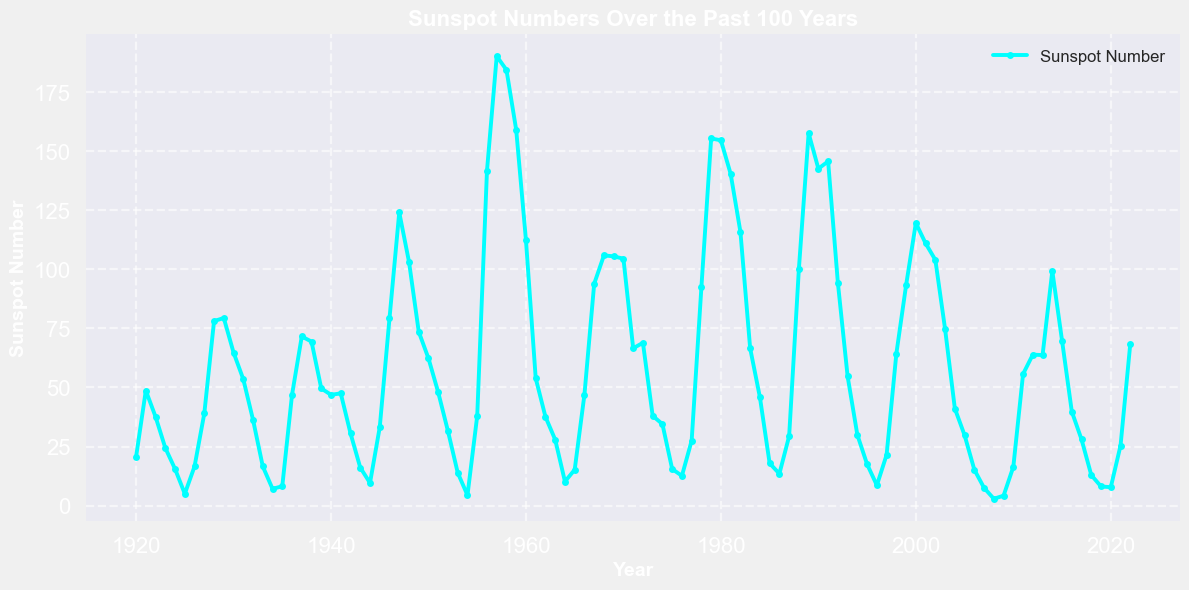What year had the highest sunspot number? To find the highest sunspot number, look for the peak value in the chart. The highest value corresponds to the year 1957 with a sunspot number of 190.2.
Answer: 1957 Which decade experienced the lowest sunspot numbers overall? Sum the sunspot numbers for each decade and compare the totals. The 1920s had a cumulative sunspot number of (20.6 + 48.7 + 37.6 + 24.4 + 15.5 + 5.0 + 16.6 + 39.0 + 78.1 + 79.4) = 365.9, which is the lowest of any decade.
Answer: 1920s What are the two closest consecutive years with a large difference in sunspot numbers? To determine the closest consecutive years with the largest difference, look for the highest changes from one year to the next. The biggest difference occurs between 1956 (141.7) and 1957 (190.2), which is a difference of 48.5.
Answer: 1956 and 1957 Between 1980 and 2000, which year had the highest increase in sunspot numbers? Inspect the plot between the years 1980 and 2000, and find the steepest upward slope. The largest increase is between 1996 (8.6) and 1997 (21.5), an increase of 12.9.
Answer: 1997 What is the average sunspot number in the years between 1945 and 1955 inclusive? Sum the numbers from 1945 to 1955 and divide by the number of years. The total is (33.2 + 79.3 + 124.1 + 103.2 + 73.6 + 62.3 + 47.9 + 31.5 + 13.9 + 4.4 + 38.0) = 612.4. Divide by 11 years: 612.4 / 11 = 55.67.
Answer: 55.67 Compare the average sunspot number of the decades 1940-1949 and 2000-2009. Which one is higher? Calculate the average for both decades. For 1940-1949: (46.9 + 47.5 + 30.6 + 16.1 + 9.6 + 33.2 + 79.3 + 124.1 + 103.2 + 73.6) / 10 = 56.41. For 2000-2009: (119.6 + 111.0 + 104.0 + 74.7 + 41.1 + 29.8 + 15.2 + 7.5 + 2.9 + 4.2) / 10 = 51.00. The 1940-1949 decade has a higher average.
Answer: 1940-1949 What year did the sunspot numbers first exceed 100? Check the chart to find the first instance where the sunspot number crosses the 100 mark. It first exceeds 100 in the year 1947 with a sunspot number of 124.1.
Answer: 1947 Which years had a sunspot number equal to or under 10 and closest to the year 2000? Identify the years around 2000 with sunspot numbers of 10 or less. The closest years are 2008 (2.9) and 2009 (4.2).
Answer: 2008 and 2009 